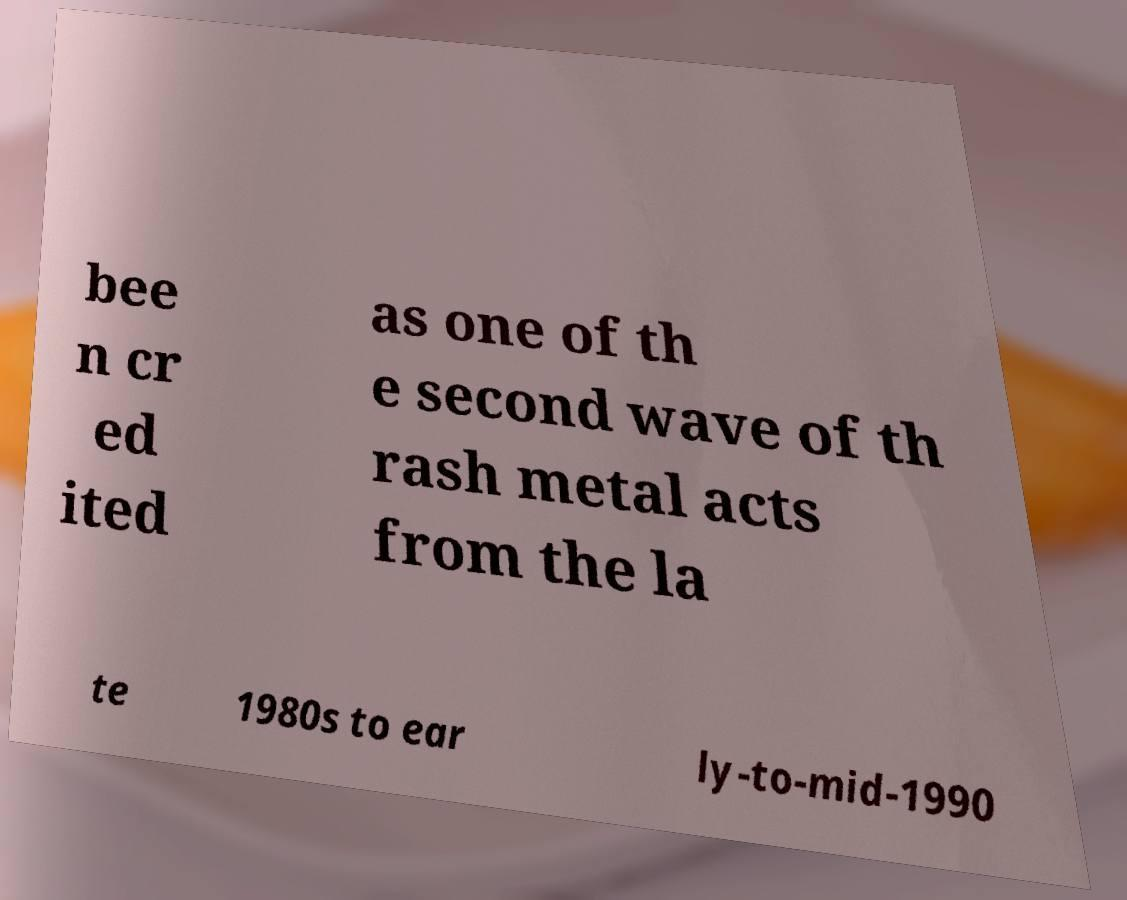There's text embedded in this image that I need extracted. Can you transcribe it verbatim? bee n cr ed ited as one of th e second wave of th rash metal acts from the la te 1980s to ear ly-to-mid-1990 